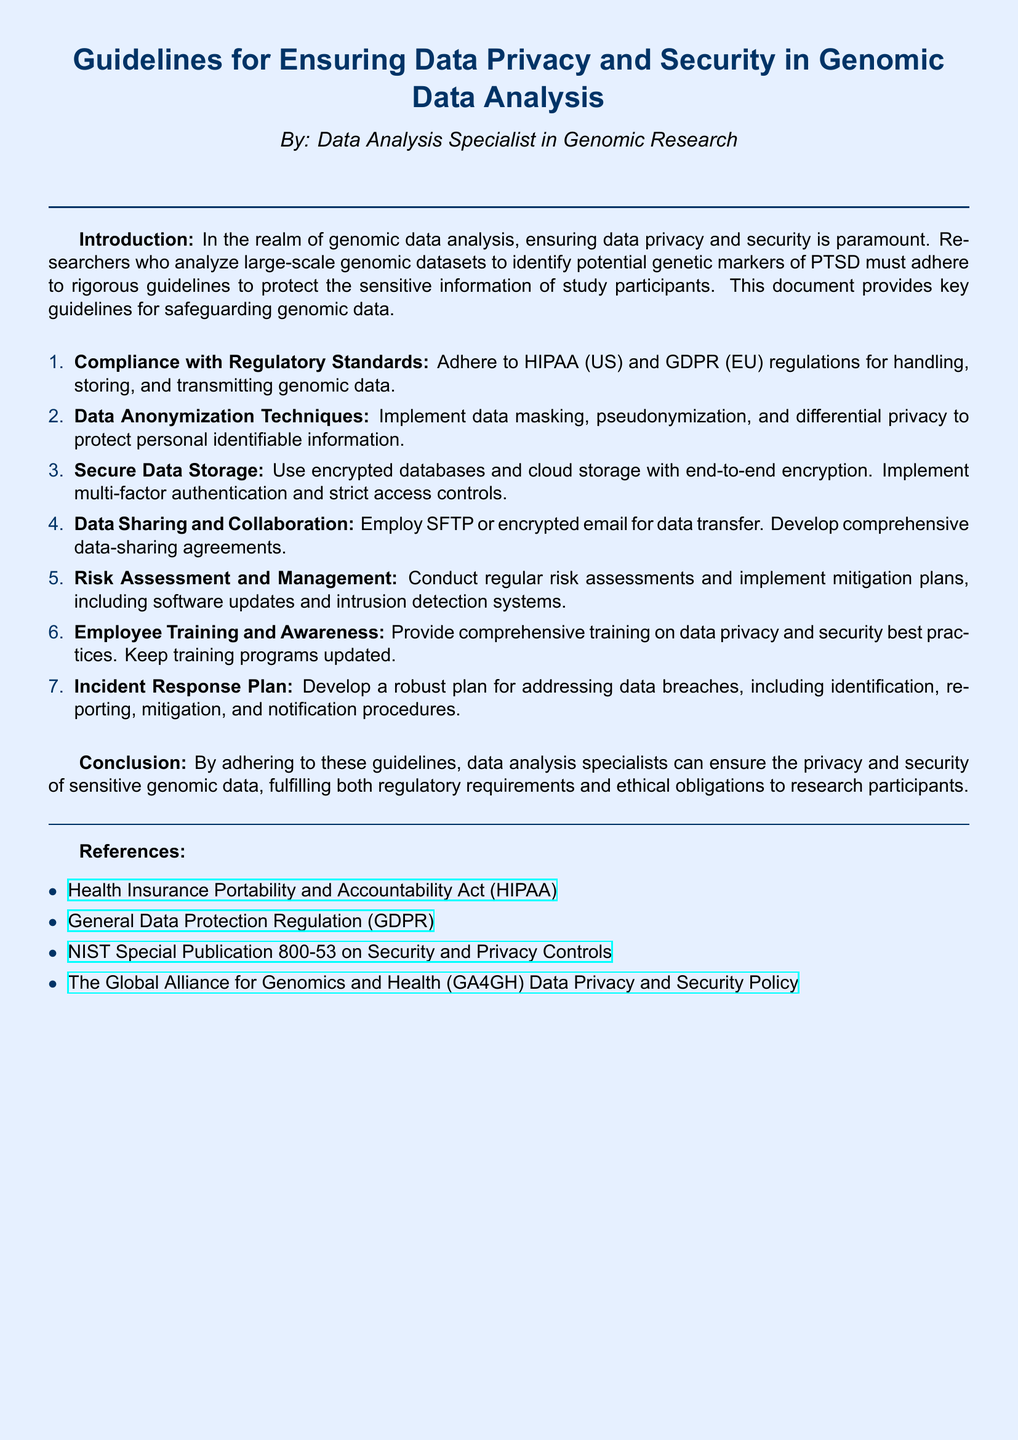What is the title of the document? The title of the document is prominently displayed at the top and provides insight into its content.
Answer: Guidelines for Ensuring Data Privacy and Security in Genomic Data Analysis Who is the author of the document? The document indicates the author in a specific note right below the title.
Answer: Data Analysis Specialist in Genomic Research What regulatory standards must be adhered to according to the guidelines? The guidelines specifically mention essential regulations to follow for data handling.
Answer: HIPAA and GDPR What is one technique recommended for data anonymization? This part of the document lists various methods to ensure data privacy, which helps in understanding the necessary practices.
Answer: Pseudonymization What should be implemented for secure data storage? The document highlights important measures to maintain the security of stored data.
Answer: Encrypted databases How often should risk assessments be conducted? The guidelines suggest a frequency for conducting assessments, indicative of regular maintenance in data security practices.
Answer: Regularly What is an essential component of the incident response plan? The document details specific aspects that should be included in the incident response plan for data breaches.
Answer: Mitigation procedures What type of training should be provided to employees? The guidelines stress the importance of training staff regarding data privacy and security, outlining a specific focus area.
Answer: Comprehensive training What is the color of the page background? The visual aspect of the document features a specific color scheme that contributes to its presentation.
Answer: Light blue 